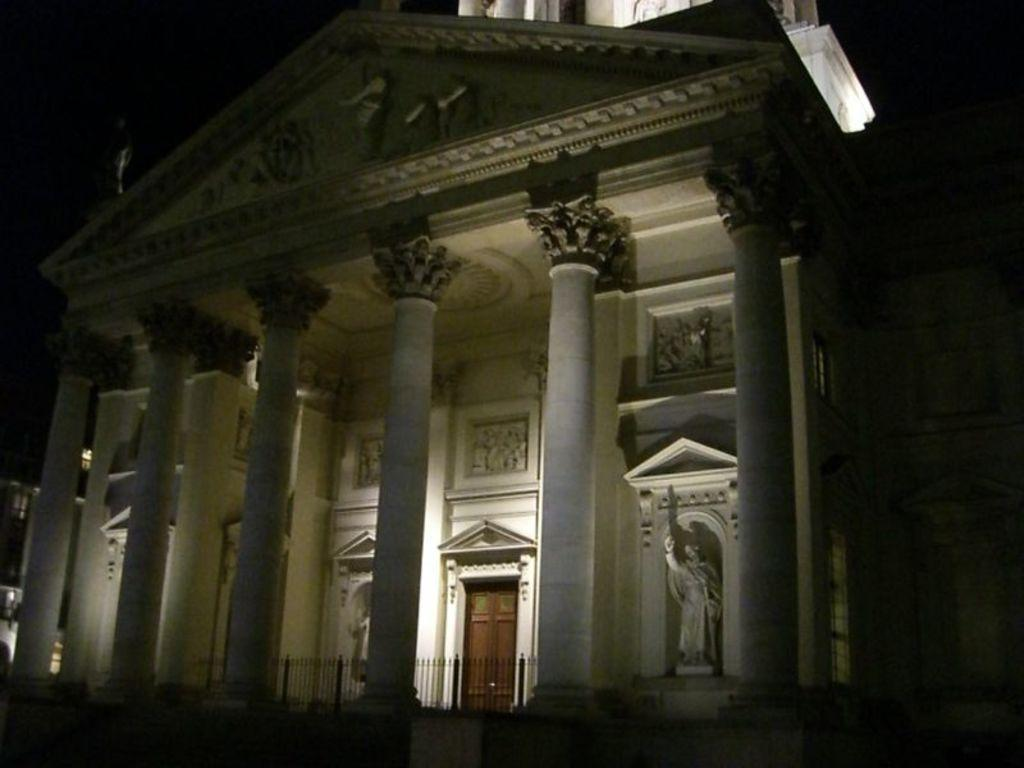What type of structure is partially visible in the image? There is a building in the image, but it is truncated. What architectural features can be seen in the image? There are pillars in the image. What is a possible entry point to the building? There is a door in the image. What type of decorative elements are present on the wall? There are sculptures on the wall in the image. What type of barrier is present in the image? There is a fence in the image. How would you describe the lighting conditions in the image? The background of the image is dark. What type of paper is being used to create the sculptures on the wall in the image? There is no paper mentioned or visible in the image; the sculptures are on the wall. How many bulbs are illuminating the building in the image? There is no information about any bulbs in the image; the background is dark. 